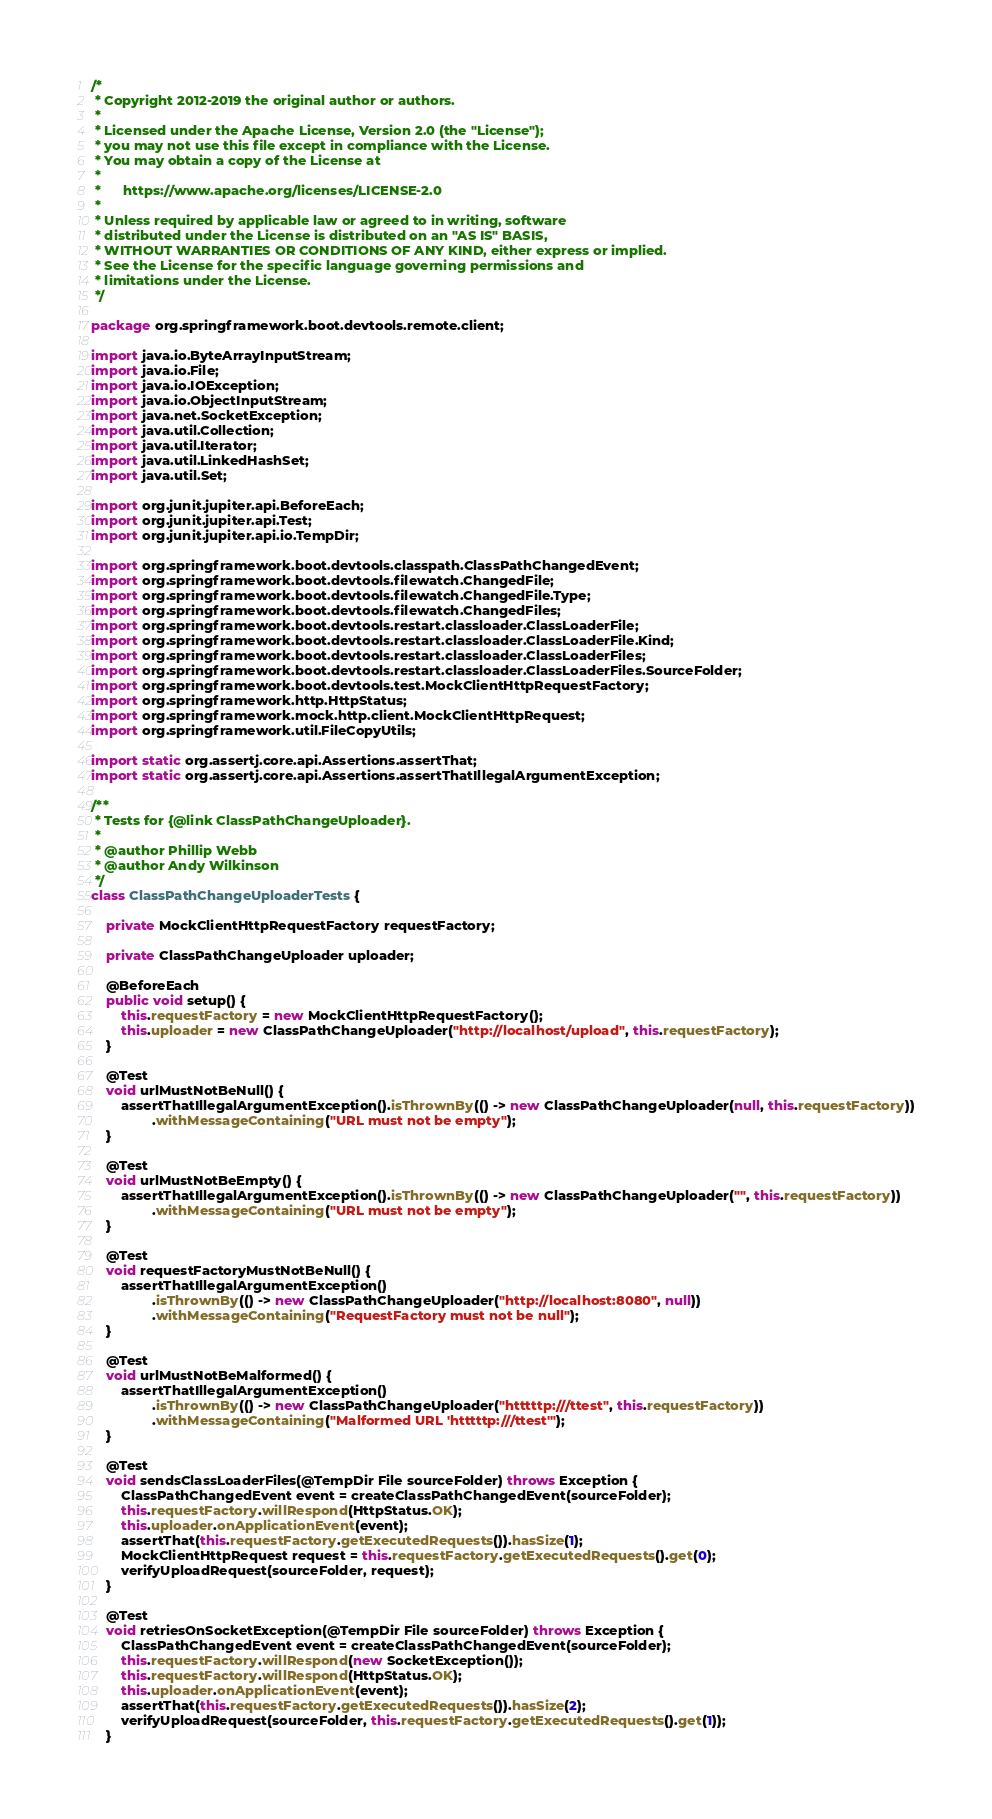Convert code to text. <code><loc_0><loc_0><loc_500><loc_500><_Java_>/*
 * Copyright 2012-2019 the original author or authors.
 *
 * Licensed under the Apache License, Version 2.0 (the "License");
 * you may not use this file except in compliance with the License.
 * You may obtain a copy of the License at
 *
 *      https://www.apache.org/licenses/LICENSE-2.0
 *
 * Unless required by applicable law or agreed to in writing, software
 * distributed under the License is distributed on an "AS IS" BASIS,
 * WITHOUT WARRANTIES OR CONDITIONS OF ANY KIND, either express or implied.
 * See the License for the specific language governing permissions and
 * limitations under the License.
 */

package org.springframework.boot.devtools.remote.client;

import java.io.ByteArrayInputStream;
import java.io.File;
import java.io.IOException;
import java.io.ObjectInputStream;
import java.net.SocketException;
import java.util.Collection;
import java.util.Iterator;
import java.util.LinkedHashSet;
import java.util.Set;

import org.junit.jupiter.api.BeforeEach;
import org.junit.jupiter.api.Test;
import org.junit.jupiter.api.io.TempDir;

import org.springframework.boot.devtools.classpath.ClassPathChangedEvent;
import org.springframework.boot.devtools.filewatch.ChangedFile;
import org.springframework.boot.devtools.filewatch.ChangedFile.Type;
import org.springframework.boot.devtools.filewatch.ChangedFiles;
import org.springframework.boot.devtools.restart.classloader.ClassLoaderFile;
import org.springframework.boot.devtools.restart.classloader.ClassLoaderFile.Kind;
import org.springframework.boot.devtools.restart.classloader.ClassLoaderFiles;
import org.springframework.boot.devtools.restart.classloader.ClassLoaderFiles.SourceFolder;
import org.springframework.boot.devtools.test.MockClientHttpRequestFactory;
import org.springframework.http.HttpStatus;
import org.springframework.mock.http.client.MockClientHttpRequest;
import org.springframework.util.FileCopyUtils;

import static org.assertj.core.api.Assertions.assertThat;
import static org.assertj.core.api.Assertions.assertThatIllegalArgumentException;

/**
 * Tests for {@link ClassPathChangeUploader}.
 *
 * @author Phillip Webb
 * @author Andy Wilkinson
 */
class ClassPathChangeUploaderTests {

	private MockClientHttpRequestFactory requestFactory;

	private ClassPathChangeUploader uploader;

	@BeforeEach
	public void setup() {
		this.requestFactory = new MockClientHttpRequestFactory();
		this.uploader = new ClassPathChangeUploader("http://localhost/upload", this.requestFactory);
	}

	@Test
	void urlMustNotBeNull() {
		assertThatIllegalArgumentException().isThrownBy(() -> new ClassPathChangeUploader(null, this.requestFactory))
				.withMessageContaining("URL must not be empty");
	}

	@Test
	void urlMustNotBeEmpty() {
		assertThatIllegalArgumentException().isThrownBy(() -> new ClassPathChangeUploader("", this.requestFactory))
				.withMessageContaining("URL must not be empty");
	}

	@Test
	void requestFactoryMustNotBeNull() {
		assertThatIllegalArgumentException()
				.isThrownBy(() -> new ClassPathChangeUploader("http://localhost:8080", null))
				.withMessageContaining("RequestFactory must not be null");
	}

	@Test
	void urlMustNotBeMalformed() {
		assertThatIllegalArgumentException()
				.isThrownBy(() -> new ClassPathChangeUploader("htttttp:///ttest", this.requestFactory))
				.withMessageContaining("Malformed URL 'htttttp:///ttest'");
	}

	@Test
	void sendsClassLoaderFiles(@TempDir File sourceFolder) throws Exception {
		ClassPathChangedEvent event = createClassPathChangedEvent(sourceFolder);
		this.requestFactory.willRespond(HttpStatus.OK);
		this.uploader.onApplicationEvent(event);
		assertThat(this.requestFactory.getExecutedRequests()).hasSize(1);
		MockClientHttpRequest request = this.requestFactory.getExecutedRequests().get(0);
		verifyUploadRequest(sourceFolder, request);
	}

	@Test
	void retriesOnSocketException(@TempDir File sourceFolder) throws Exception {
		ClassPathChangedEvent event = createClassPathChangedEvent(sourceFolder);
		this.requestFactory.willRespond(new SocketException());
		this.requestFactory.willRespond(HttpStatus.OK);
		this.uploader.onApplicationEvent(event);
		assertThat(this.requestFactory.getExecutedRequests()).hasSize(2);
		verifyUploadRequest(sourceFolder, this.requestFactory.getExecutedRequests().get(1));
	}
</code> 